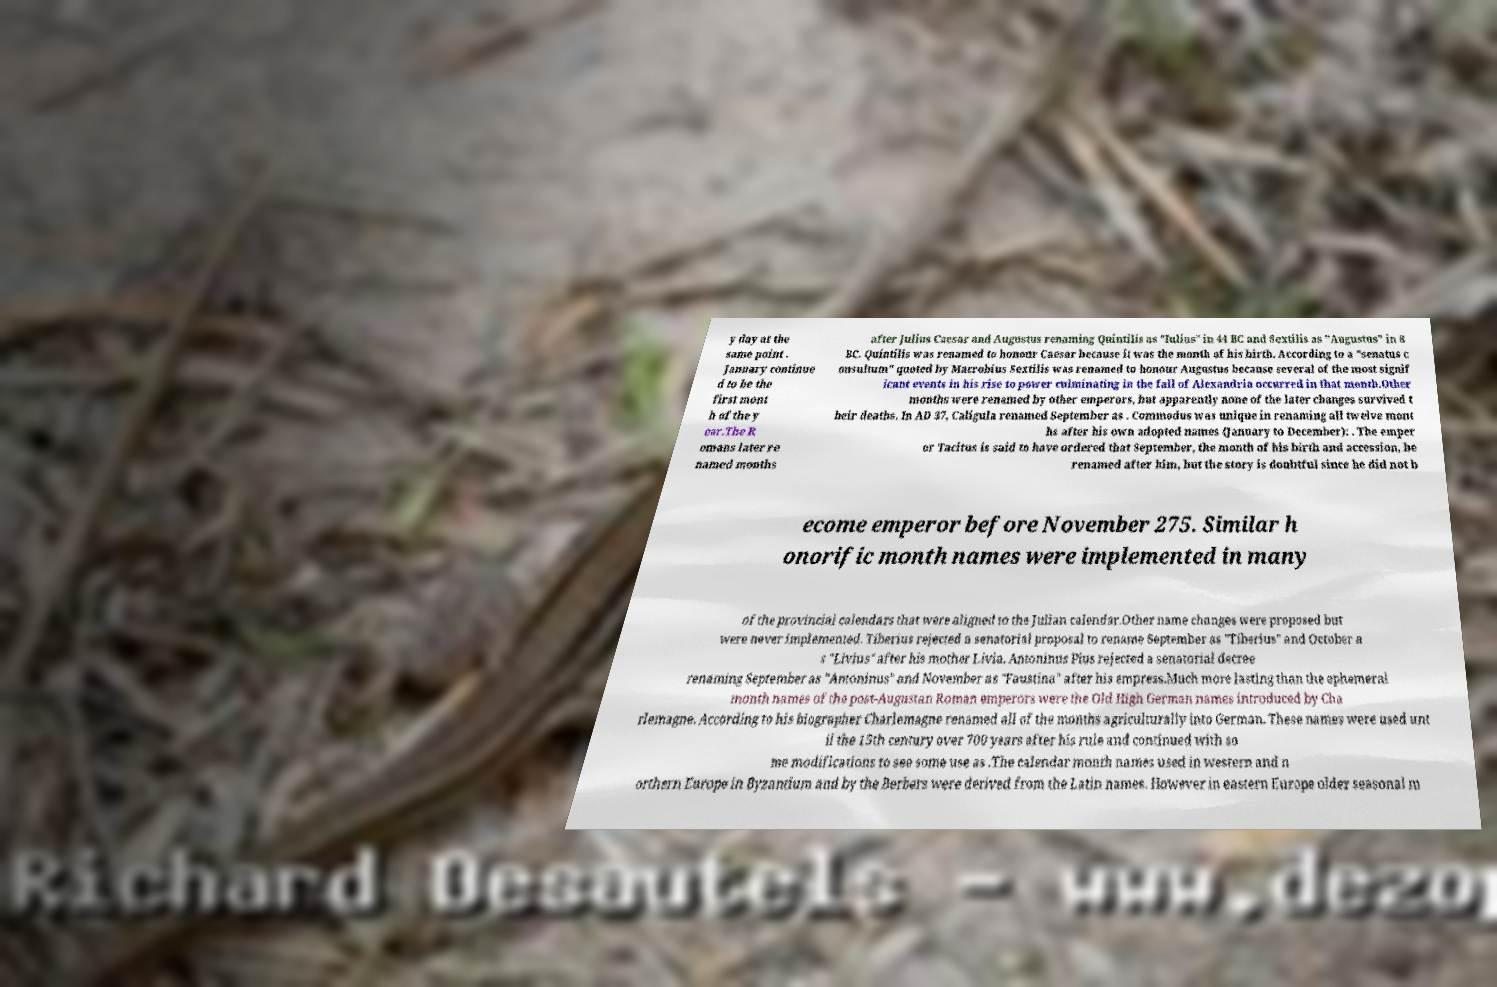I need the written content from this picture converted into text. Can you do that? y day at the same point . January continue d to be the first mont h of the y ear.The R omans later re named months after Julius Caesar and Augustus renaming Quintilis as "Iulius" in 44 BC and Sextilis as "Augustus" in 8 BC. Quintilis was renamed to honour Caesar because it was the month of his birth. According to a "senatus c onsultum" quoted by Macrobius Sextilis was renamed to honour Augustus because several of the most signif icant events in his rise to power culminating in the fall of Alexandria occurred in that month.Other months were renamed by other emperors, but apparently none of the later changes survived t heir deaths. In AD 37, Caligula renamed September as . Commodus was unique in renaming all twelve mont hs after his own adopted names (January to December): . The emper or Tacitus is said to have ordered that September, the month of his birth and accession, be renamed after him, but the story is doubtful since he did not b ecome emperor before November 275. Similar h onorific month names were implemented in many of the provincial calendars that were aligned to the Julian calendar.Other name changes were proposed but were never implemented. Tiberius rejected a senatorial proposal to rename September as "Tiberius" and October a s "Livius" after his mother Livia. Antoninus Pius rejected a senatorial decree renaming September as "Antoninus" and November as "Faustina" after his empress.Much more lasting than the ephemeral month names of the post-Augustan Roman emperors were the Old High German names introduced by Cha rlemagne. According to his biographer Charlemagne renamed all of the months agriculturally into German. These names were used unt il the 15th century over 700 years after his rule and continued with so me modifications to see some use as .The calendar month names used in western and n orthern Europe in Byzantium and by the Berbers were derived from the Latin names. However in eastern Europe older seasonal m 